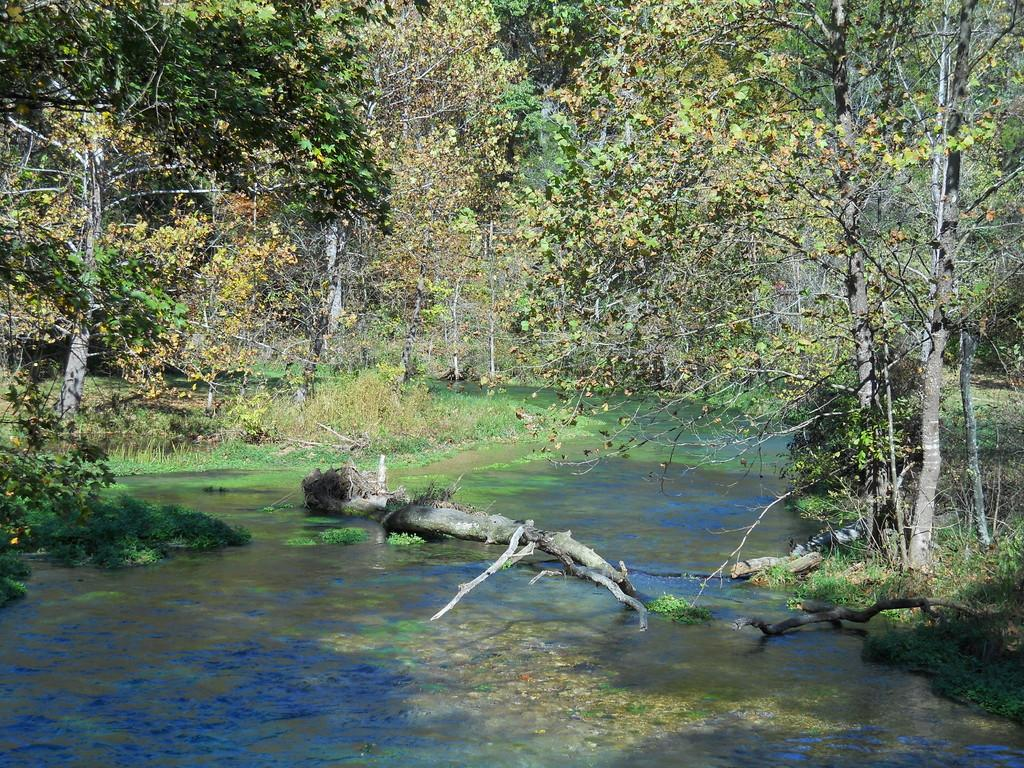What type of vegetation can be seen in the image? There are trees, plants, and grass in the image. What else can be seen in the image besides vegetation? There are branches and water in the image. Can you describe the branches in the image? The branches are part of the trees and plants in the image. What is the water in the image? The water is a part of the natural environment depicted in the image. How many faces can be seen in the image? There are no faces present in the image; it features natural elements such as trees, plants, grass, branches, and water. What type of bubble is visible in the image? There is no bubble present in the image. 